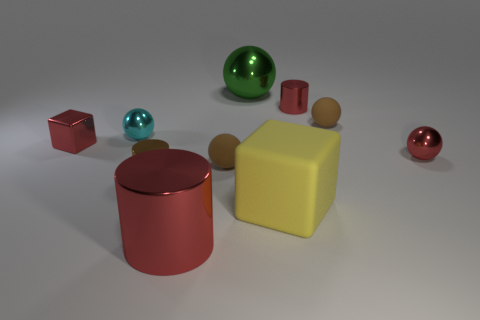Is there anything else that has the same size as the green sphere?
Provide a short and direct response. Yes. There is a small red object that is the same shape as the green object; what is it made of?
Give a very brief answer. Metal. What number of other objects are the same material as the big red cylinder?
Give a very brief answer. 6. Does the tiny cyan thing have the same material as the cube that is in front of the small red cube?
Your response must be concise. No. How many objects are either small metallic objects that are to the right of the large cube or small red metallic objects that are left of the large metal ball?
Provide a short and direct response. 3. How many other things are the same color as the large shiny cylinder?
Keep it short and to the point. 3. Are there more large metal objects that are in front of the tiny red metallic cube than large shiny cylinders that are to the right of the big matte block?
Your answer should be compact. Yes. What number of cubes are brown objects or brown rubber objects?
Offer a very short reply. 0. What number of objects are big shiny cylinders on the left side of the green ball or small red cubes?
Ensure brevity in your answer.  2. The small cyan metal object that is on the left side of the small red cylinder that is behind the yellow block right of the green thing is what shape?
Make the answer very short. Sphere. 